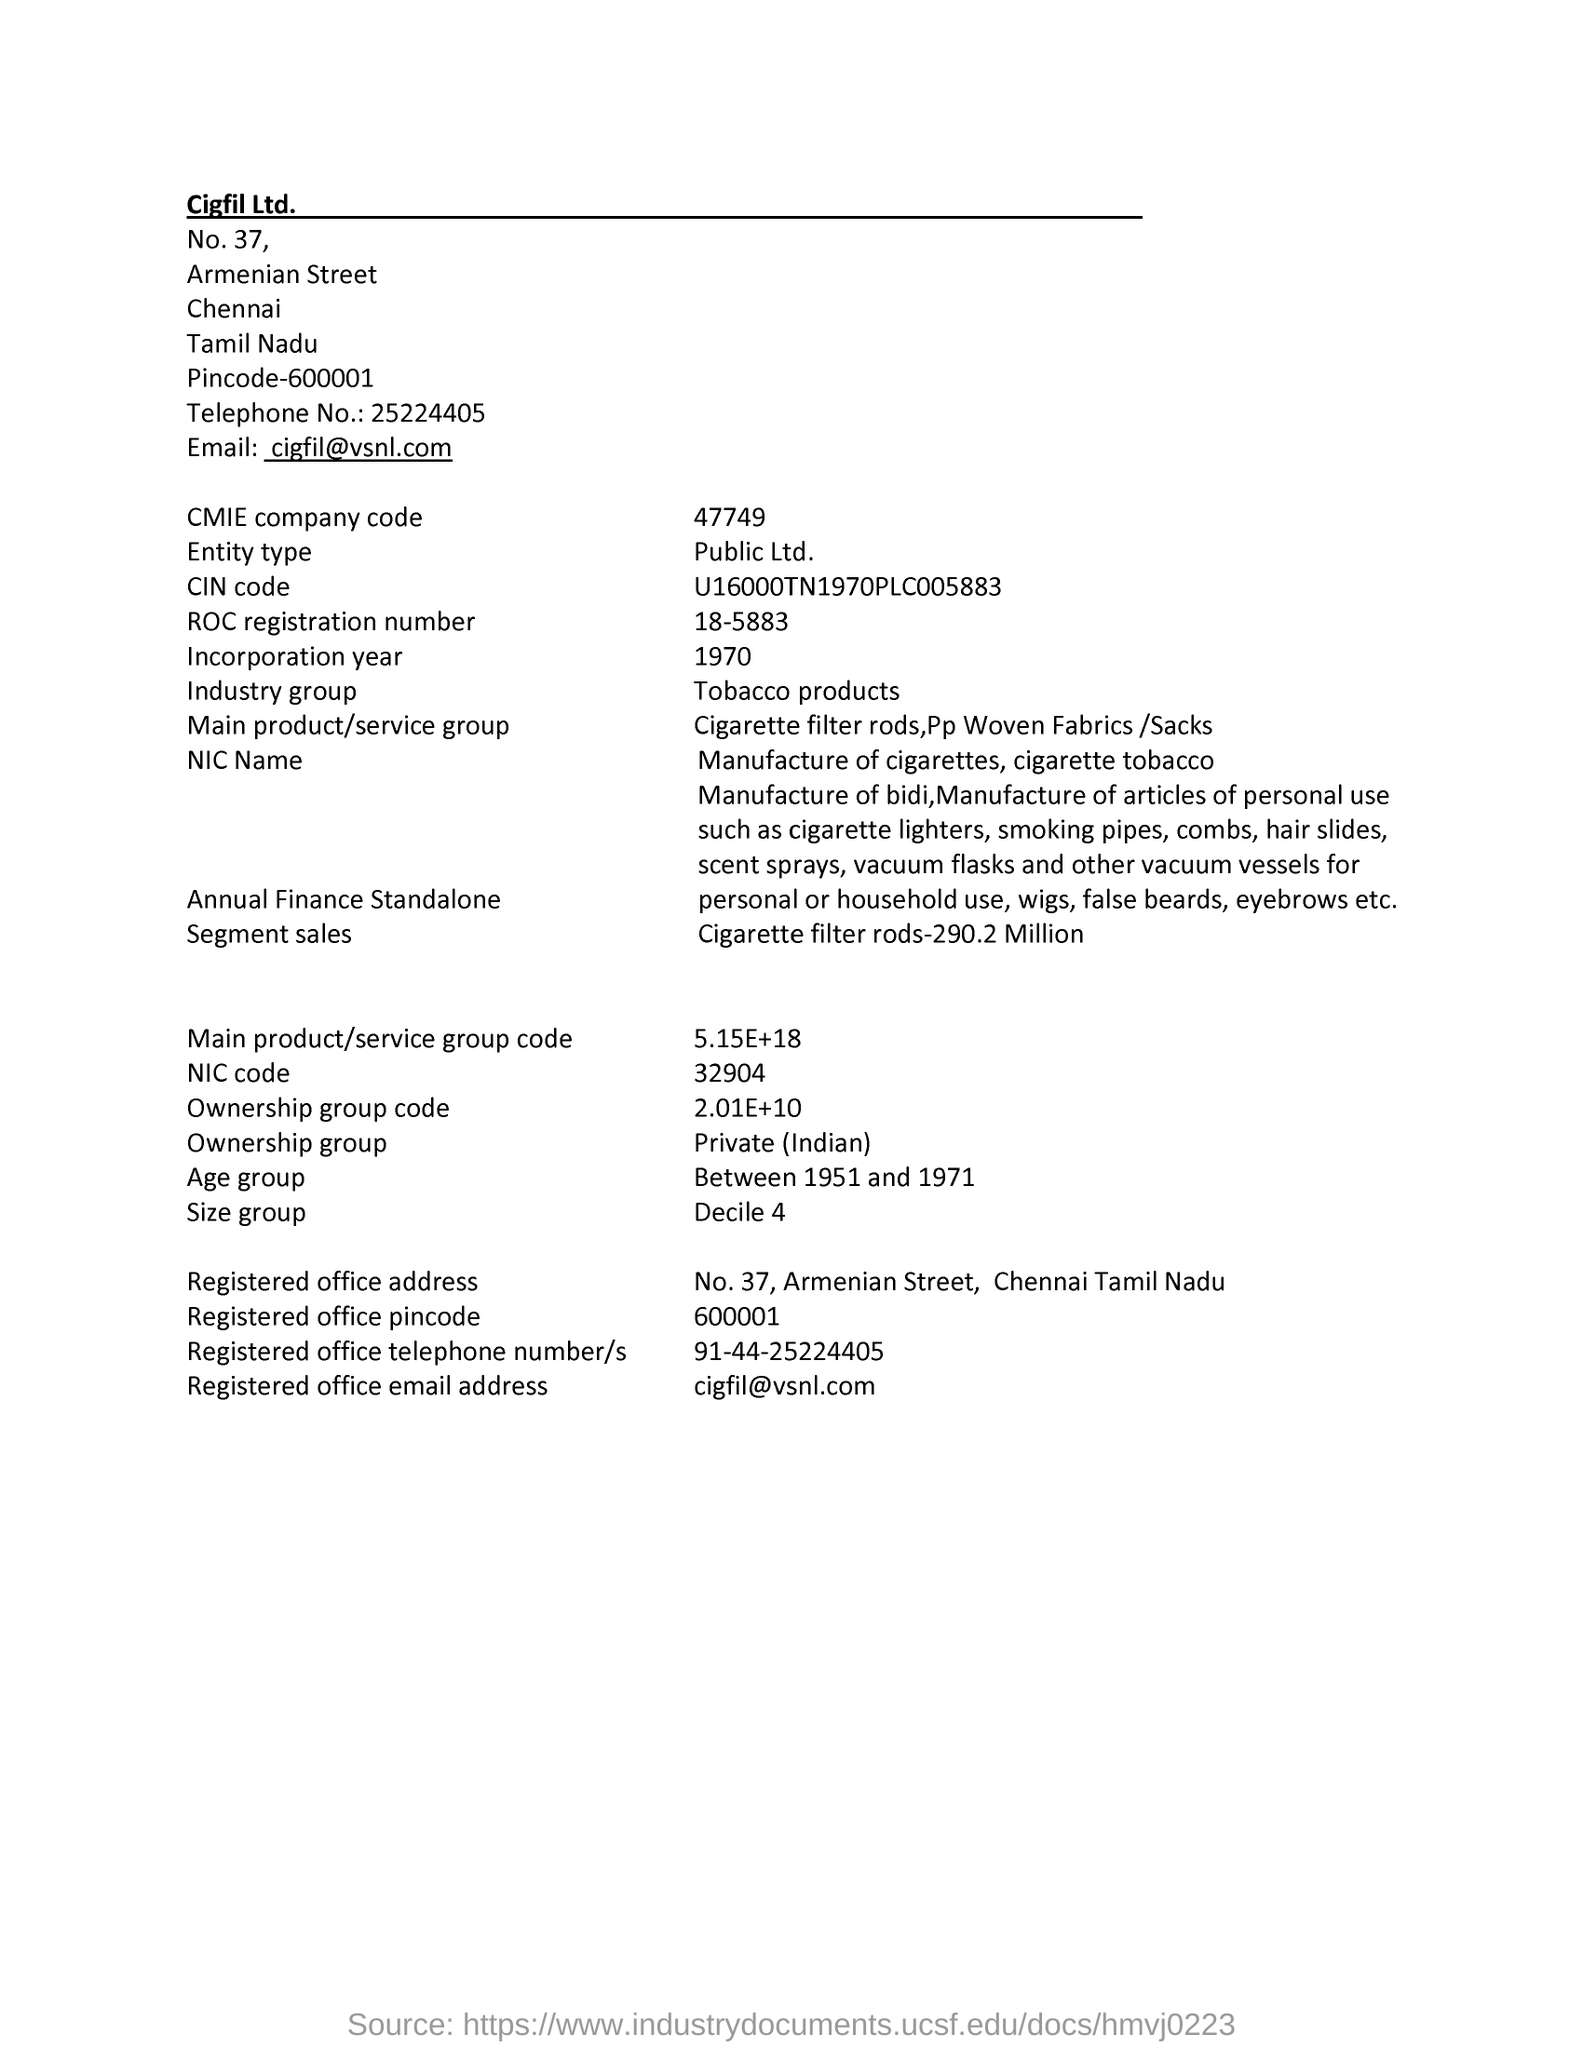List a handful of essential elements in this visual. The registered office email address of the company is [cigfil@vsnl.com](mailto:cigfil@vsnl.com) The entity type of the company mentioned in this page is a public limited company. The age group mentioned in this document is between 1951 and 1971. 